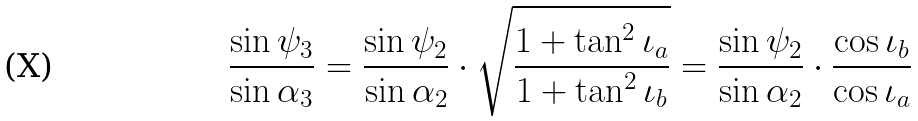<formula> <loc_0><loc_0><loc_500><loc_500>\frac { \sin \psi _ { 3 } } { \sin \alpha _ { 3 } } = \frac { \sin \psi _ { 2 } } { \sin \alpha _ { 2 } } \cdot \sqrt { \frac { 1 + \tan ^ { 2 } \iota _ { a } } { 1 + \tan ^ { 2 } \iota _ { b } } } = \frac { \sin \psi _ { 2 } } { \sin \alpha _ { 2 } } \cdot \frac { \cos \iota _ { b } } { \cos \iota _ { a } }</formula> 